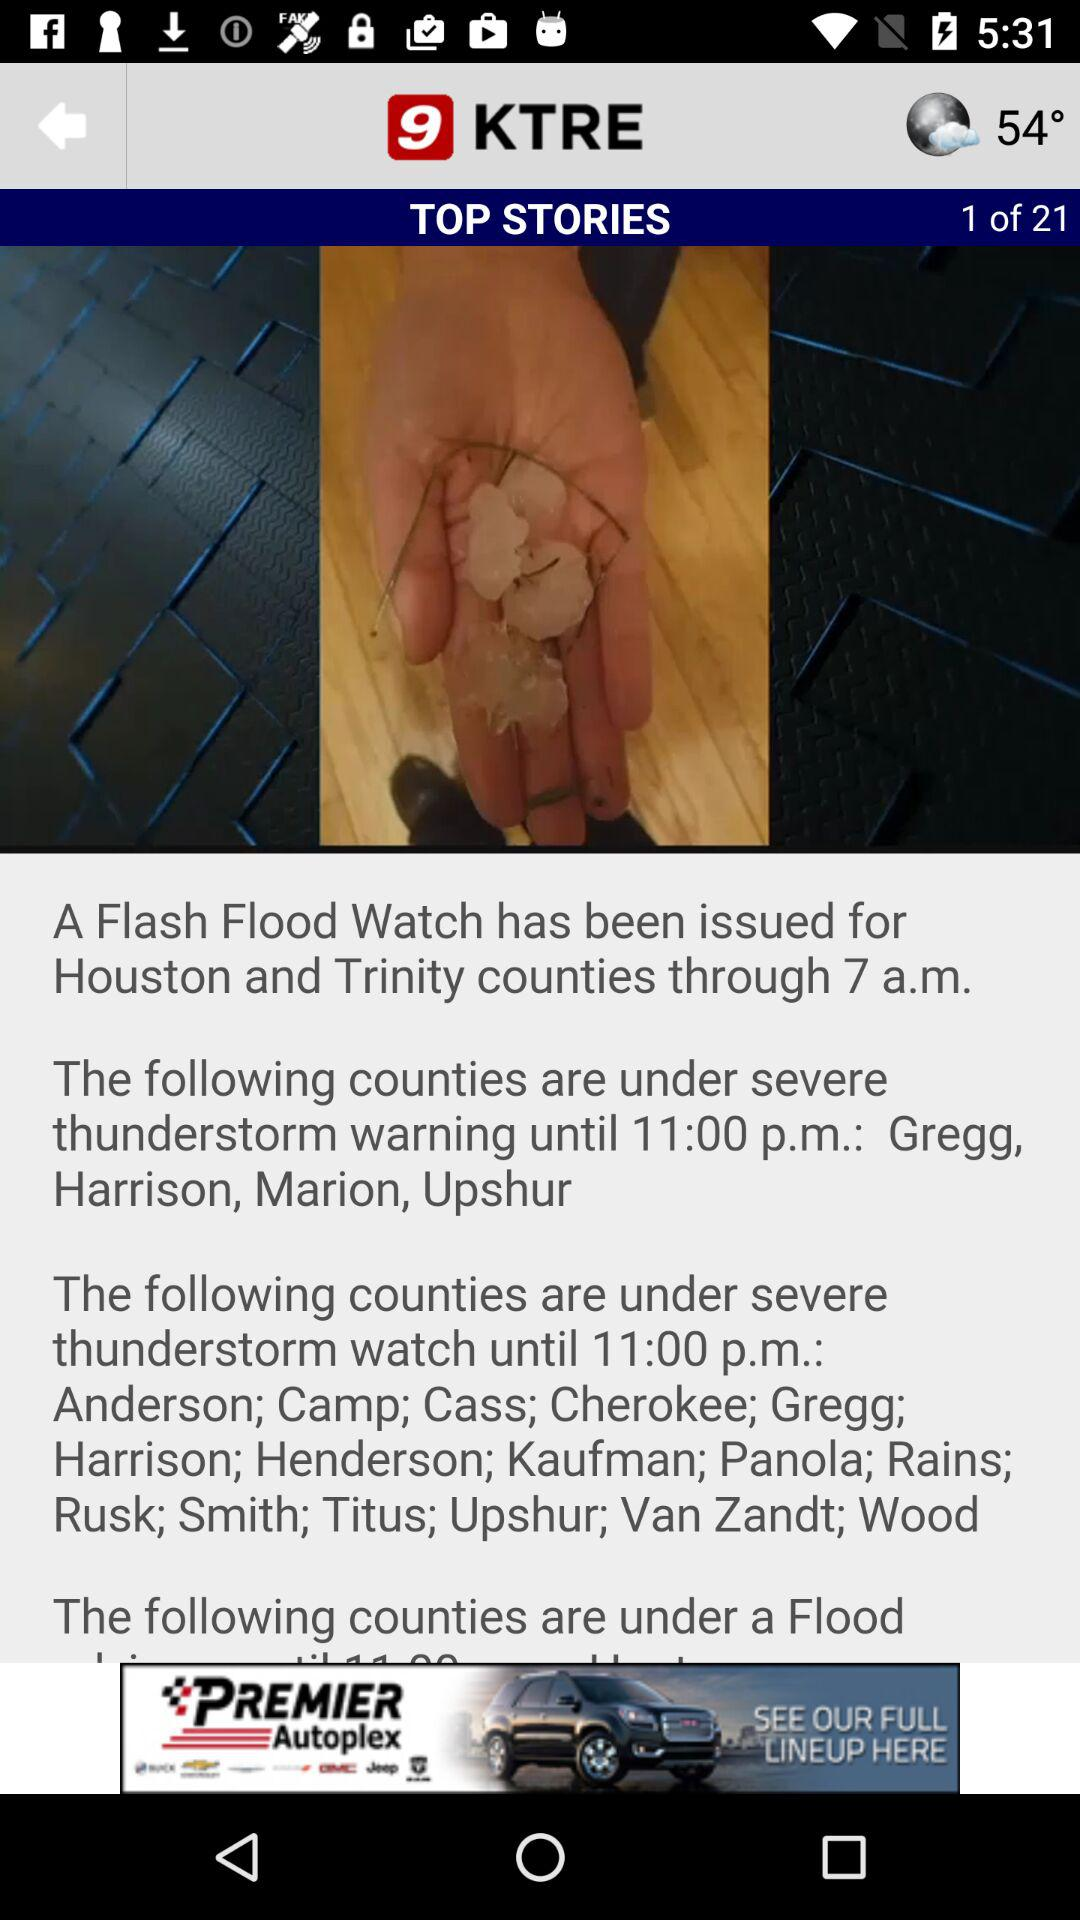How many stories in total are there? There are 21 stories in total. 